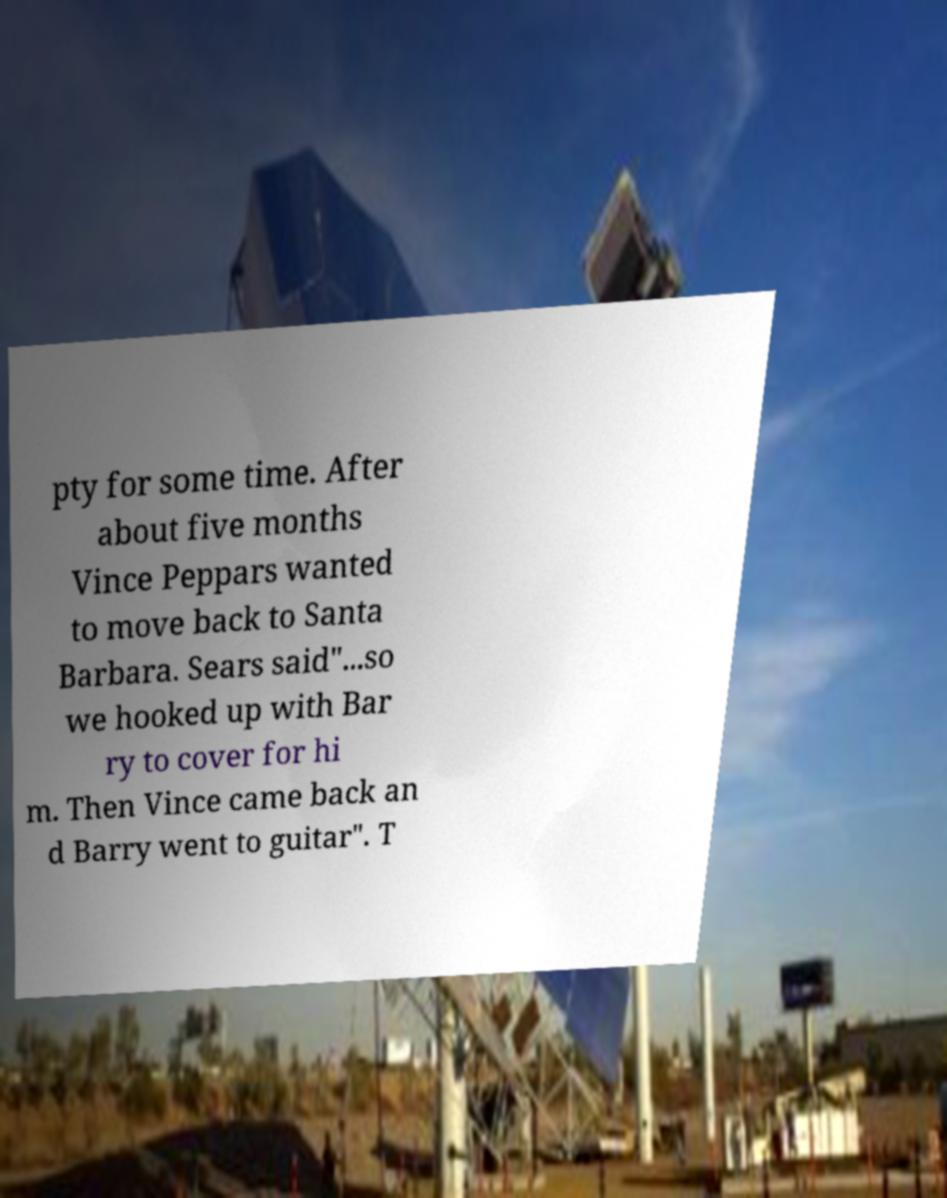Please identify and transcribe the text found in this image. pty for some time. After about five months Vince Peppars wanted to move back to Santa Barbara. Sears said"...so we hooked up with Bar ry to cover for hi m. Then Vince came back an d Barry went to guitar". T 